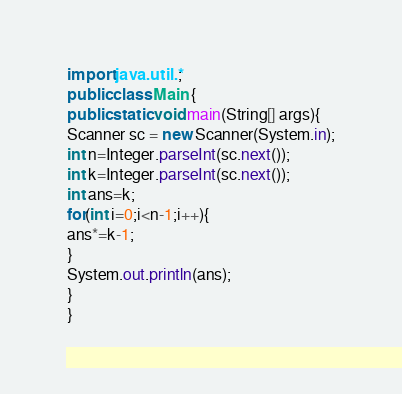Convert code to text. <code><loc_0><loc_0><loc_500><loc_500><_Java_>import java.util.*;
public class Main {
public static void main(String[] args){
Scanner sc = new Scanner(System.in);
int n=Integer.parseInt(sc.next());
int k=Integer.parseInt(sc.next());
int ans=k;
for(int i=0;i<n-1;i++){
ans*=k-1;
}
System.out.println(ans);
}
}</code> 